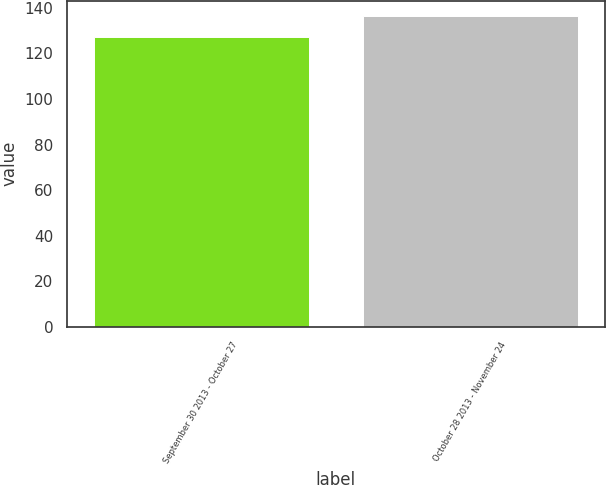Convert chart. <chart><loc_0><loc_0><loc_500><loc_500><bar_chart><fcel>September 30 2013 - October 27<fcel>October 28 2013 - November 24<nl><fcel>127.1<fcel>136.36<nl></chart> 